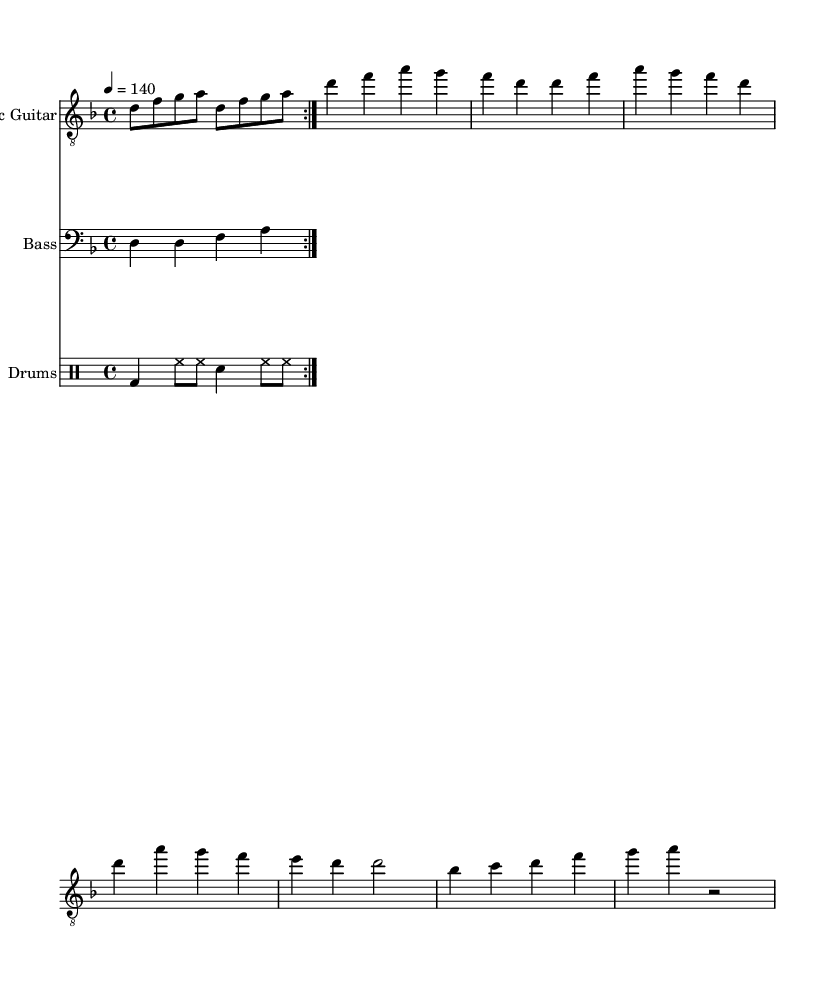What is the key signature of this music? The key signature is D minor, which consists of one flat (B flat). This can be determined by looking at the key signature section in the beginning of the sheet music.
Answer: D minor What is the time signature of this music? The time signature is 4/4, which indicates four beats per measure and that a quarter note receives one beat. This is explicitly noted at the beginning of the score.
Answer: 4/4 What is the tempo indicated in the music? The tempo is marked as quarter note = 140, which means that each quarter note should be played at a speed of 140 beats per minute. This value is provided directly in the tempo indication at the start of the score.
Answer: 140 How many measures are repeated in the electric guitar part? The electric guitar part repeats a total of 2 measures, as indicated by the repeat markings (volta) in the music notation. These markings visually show that the section is to be played twice.
Answer: 2 measures What is the lyric theme presented in the verse? The theme in the verse focuses on the concept of digital consciousness and the confusion of truth and bias, as articulated by the lyrics provided beneath the electric guitar part.
Answer: Digital consciousness What is the distinct characteristic of the drums section? The drums section features a straightforward rock beat pattern typical of metal genres, utilizing bass drum, hi-hat, and snare combinations, creating a driving rhythm essential to the genre's sound. This can be observed in the drum notation style.
Answer: Driving rhythm What is the relationship of the chorus lyrics to the broader theme? The chorus lyrics discuss a "fourth estate meltdown" amidst information overload, reflecting the critical examination of journalism's role in the digital age, linking it to the song's overarching political message. This connection can be drawn from interpreting the thematic elements of the lyrics relative to current socio-political contexts.
Answer: Political message 